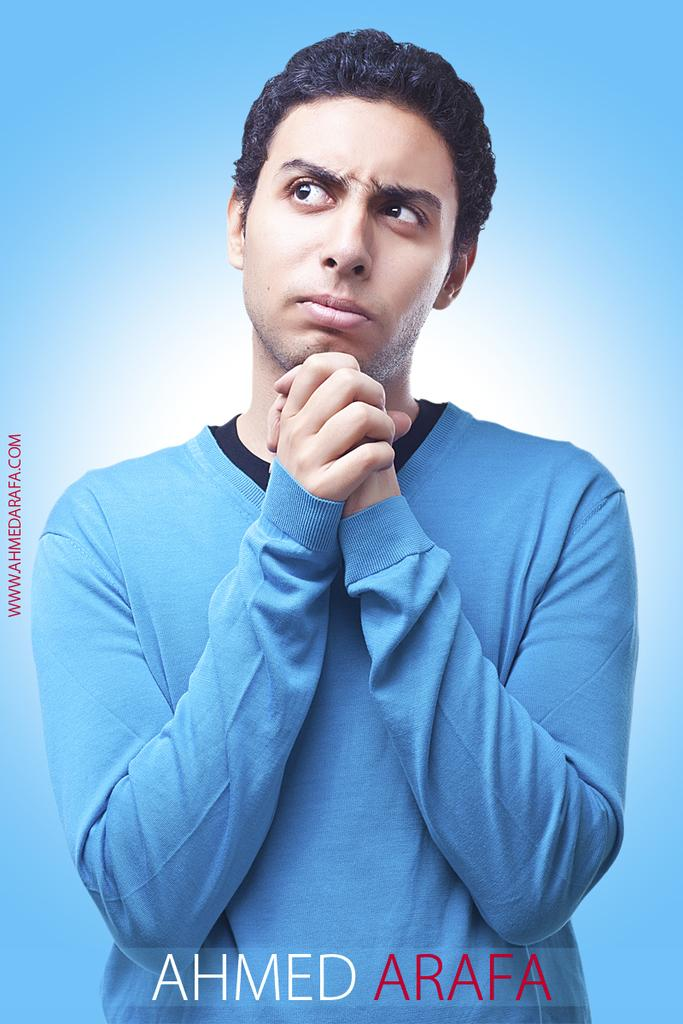What can be seen in the image? There is a person in the image. What is the person wearing? The person is wearing a t-shirt. Is there any text in the image? Yes, there is text at the bottom of the image. What color is the background of the image? The background of the image is blue in color. What type of plate is being used to rake the leaves in the image? There is no plate or rake present in the image; it features a person wearing a t-shirt with text at the bottom and a blue background. 